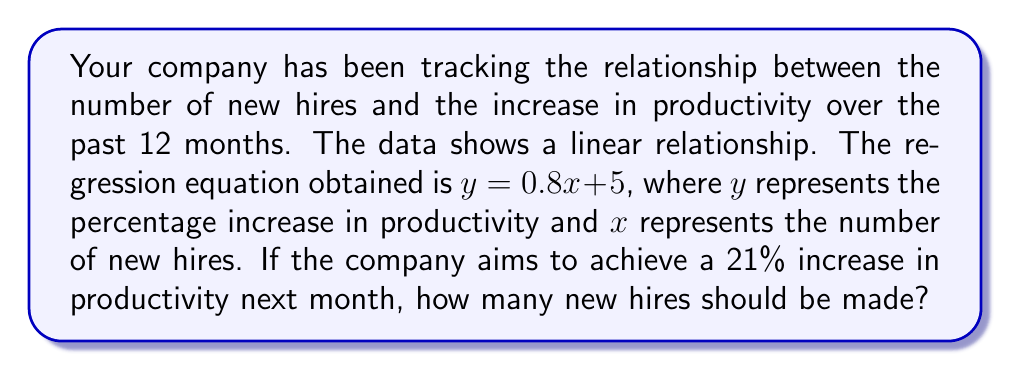What is the answer to this math problem? To solve this problem, we'll use the given linear regression equation and follow these steps:

1. Identify the given information:
   - Linear regression equation: $y = 0.8x + 5$
   - $y$ represents the percentage increase in productivity
   - $x$ represents the number of new hires
   - Target productivity increase: 21%

2. Substitute the target productivity increase into the equation:
   $$21 = 0.8x + 5$$

3. Solve for $x$ (number of new hires):
   $$21 - 5 = 0.8x$$
   $$16 = 0.8x$$

4. Divide both sides by 0.8:
   $$\frac{16}{0.8} = x$$
   $$20 = x$$

5. Since we can't hire a fraction of a person, we need to round to the nearest whole number. In this case, 20 is already a whole number, so no rounding is necessary.

Therefore, the company should hire 20 new employees to achieve the target 21% increase in productivity.
Answer: 20 new hires 